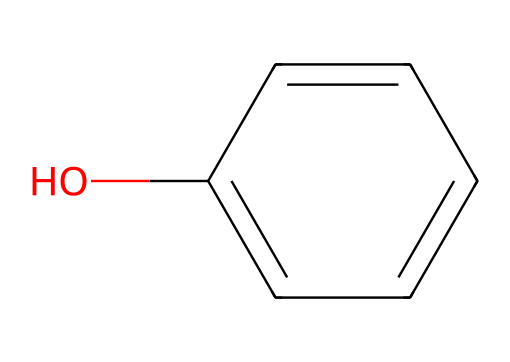What is the name of the chemical represented by the SMILES? The SMILES c1ccc(cc1)O represents a compound with a benzene ring and a hydroxyl (-OH) group, which corresponds to the name "phenol."
Answer: phenol How many carbon atoms are in the structure? By analyzing the benzene ring in the SMILES, we see six carbon atoms present in the cyclic structure.
Answer: six What type of functional group is present in this chemical? The presence of the hydroxyl (-OH) group indicates that the chemical contains an alcohol functional group, specifically characteristic of phenols.
Answer: hydroxyl What is the total number of hydrogen atoms attached to the carbons in this structure? In the structure of phenol, there are four hydrogen atoms directly attached to the carbon atoms of the benzene ring, and one hydrogen atom from the hydroxyl group, totaling five hydrogen atoms.
Answer: five Is this chemical polar or nonpolar? The presence of the hydroxyl group increases polarity due to hydrogen bonding capability, giving phenol polar characteristics.
Answer: polar How does the hydroxyl group affect the solubility of phenol in water? The hydroxyl group allows for hydrogen bonding with water molecules, increasing the solubility of phenol in aqueous solutions compared to nonpolar solvents.
Answer: increases solubility In disinfectants, what is the antimicrobial property associated with phenols? The phenolic structure is known for its ability to disrupt cell membranes and denature proteins, which contributes to its effectiveness as an antimicrobial agent.
Answer: antimicrobial agent 